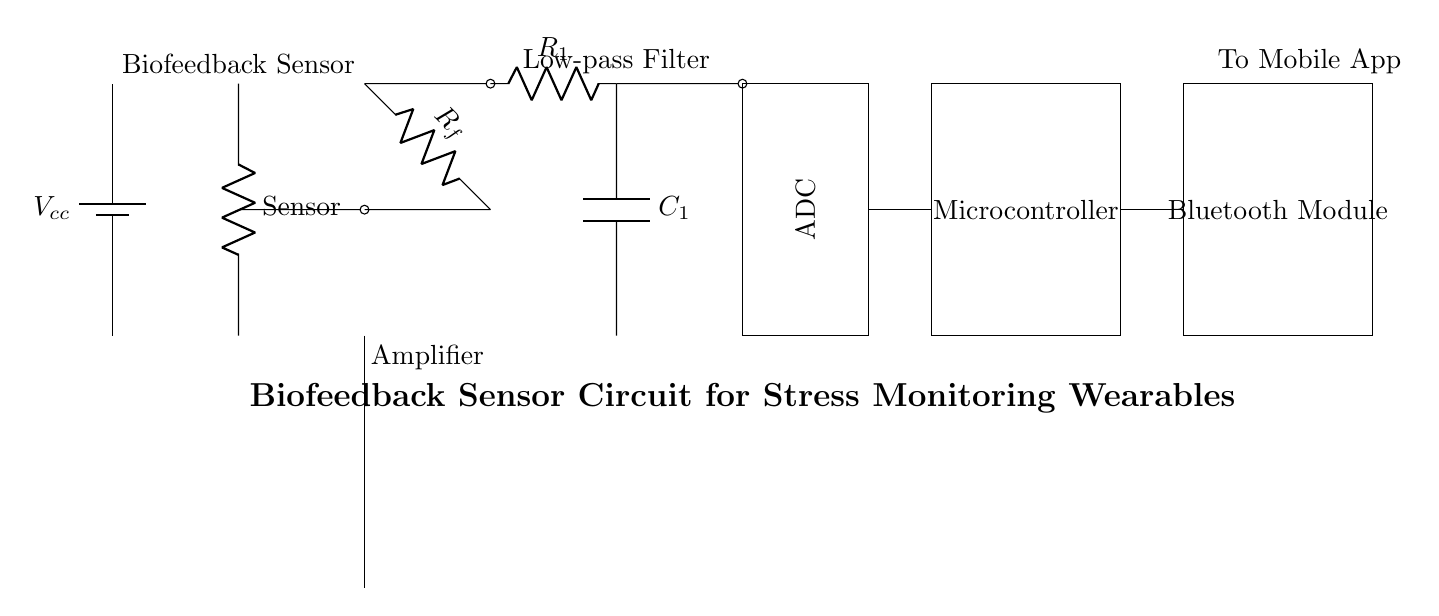What component is used to amplify the signal? The circuit includes an operational amplifier, which is the component that amplifies the signal coming from the sensor. It's clearly labeled as "op amp" in the diagram.
Answer: operational amplifier What is the purpose of the feedback resistor? The feedback resistor is connected across the output and input of the operational amplifier. Its role is to set the gain of the amplifier, thus determining how much the input signal will be amplified.
Answer: gain control How many main sections are present in the circuit? The circuit consists of five main sections: the sensor, amplifier, filter, ADC, and microcontroller/Bluetooth module. Each section has a distinct function.
Answer: five What type of filter is used in the circuit? The filter shown in the circuit is a low-pass filter, which is indicated by the resistor and capacitor connected in series. This type of filter allows low-frequency signals to pass while attenuating high-frequency signals.
Answer: low-pass filter Which component communicates with a mobile app? The Bluetooth module is responsible for wireless communication with a mobile app, as indicated in the diagram by its labeling.
Answer: Bluetooth module What is the voltage source labeled as? The power supply in this circuit is labeled as "Vcc," which typically denotes the voltage supply necessary for the operation of the circuit components.
Answer: Vcc How does the ADC fit into the signal processing chain? The ADC (Analog-to-Digital Converter) converts the analog output from the amplifier (after filtering) into a digital signal, which can then be processed by the microcontroller. This step is essential for digital processing and analysis.
Answer: signal conversion 